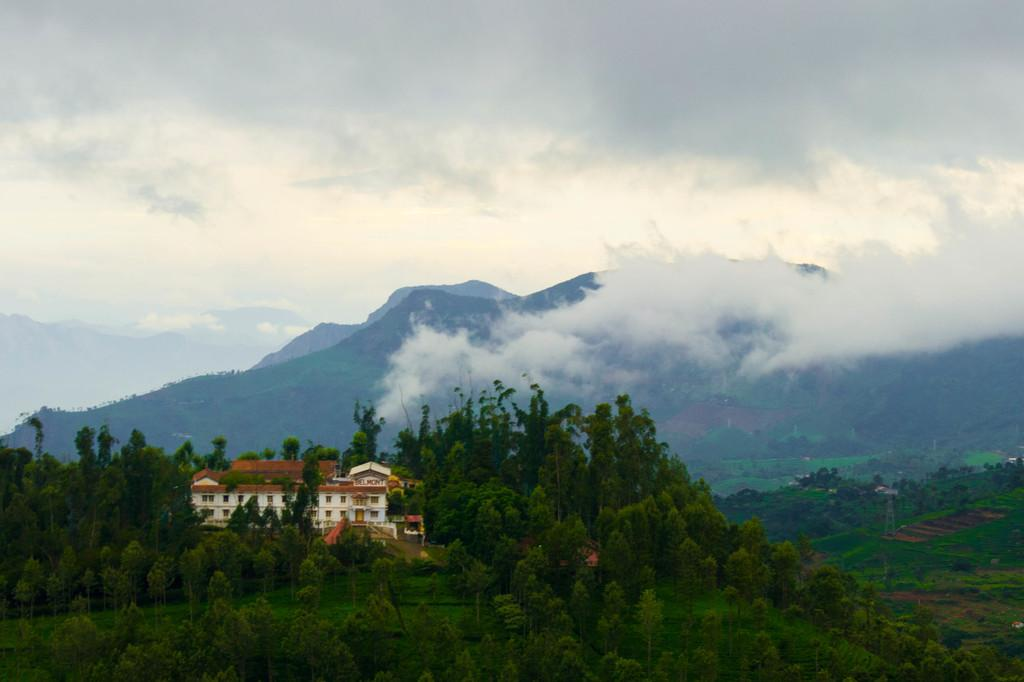What type of structure is visible in the image? There is a building in the image. What feature can be seen on the building? The building has windows. What type of vegetation is present in the image? There are trees in the image. What geographical feature can be seen in the background? There are mountains in the image. What type of ground cover is visible in the image? There is grass in the image. What is the condition of the sky in the image? The sky is cloudy in the image. Is there any visible smoke in the image? Yes, there is smoke in the image. What type of skirt is being worn by the mountain in the image? There are no skirts present in the image, as the mountain is a geographical feature and not a person. 